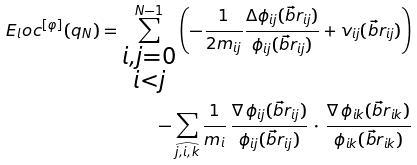<formula> <loc_0><loc_0><loc_500><loc_500>E _ { l } o c ^ { [ \varphi ] } ( q _ { N } ) = \sum ^ { N - 1 } _ { \substack { i , j = 0 \\ i < j } } \left ( - \frac { 1 } { 2 m _ { i j } } \frac { \Delta \phi _ { i j } ( \vec { b } { r } _ { i j } ) } { \phi _ { i j } ( \vec { b } { r } _ { i j } ) } + v _ { i j } ( \vec { b } { r } _ { i j } ) \right ) \\ - \sum _ { \widehat { j , i , k } } \frac { 1 } { m _ { i } } \, \frac { \nabla \, \phi _ { i j } ( \vec { b } { r } _ { i j } ) } { \phi _ { i j } ( \vec { b } { r } _ { i j } ) } \, \cdot \, \frac { \nabla \, \phi _ { i k } ( \vec { b } { r } _ { i k } ) } { \phi _ { i k } ( \vec { b } { r } _ { i k } ) }</formula> 